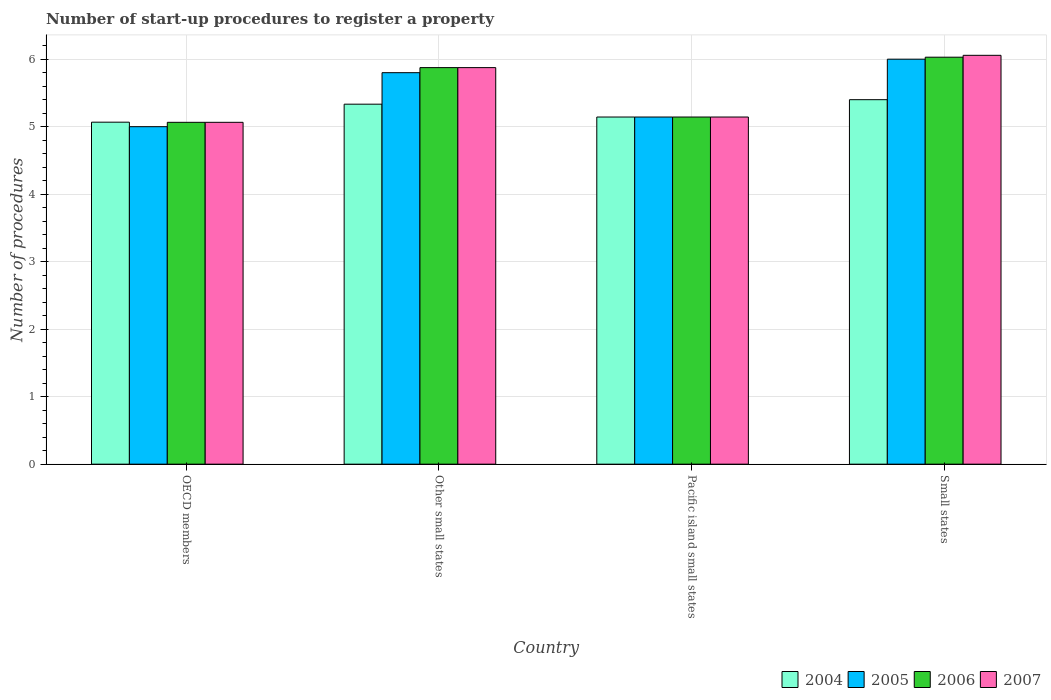How many groups of bars are there?
Make the answer very short. 4. Are the number of bars per tick equal to the number of legend labels?
Your response must be concise. Yes. How many bars are there on the 3rd tick from the left?
Provide a short and direct response. 4. What is the label of the 1st group of bars from the left?
Your response must be concise. OECD members. In how many cases, is the number of bars for a given country not equal to the number of legend labels?
Your answer should be very brief. 0. What is the number of procedures required to register a property in 2007 in Other small states?
Your answer should be compact. 5.88. Across all countries, what is the maximum number of procedures required to register a property in 2006?
Ensure brevity in your answer.  6.03. Across all countries, what is the minimum number of procedures required to register a property in 2005?
Make the answer very short. 5. In which country was the number of procedures required to register a property in 2006 maximum?
Give a very brief answer. Small states. In which country was the number of procedures required to register a property in 2005 minimum?
Offer a terse response. OECD members. What is the total number of procedures required to register a property in 2007 in the graph?
Offer a terse response. 22.14. What is the difference between the number of procedures required to register a property in 2004 in OECD members and that in Other small states?
Provide a succinct answer. -0.27. What is the difference between the number of procedures required to register a property in 2006 in Other small states and the number of procedures required to register a property in 2005 in Small states?
Your response must be concise. -0.12. What is the average number of procedures required to register a property in 2007 per country?
Give a very brief answer. 5.53. What is the difference between the number of procedures required to register a property of/in 2004 and number of procedures required to register a property of/in 2006 in Pacific island small states?
Offer a very short reply. 0. What is the ratio of the number of procedures required to register a property in 2005 in OECD members to that in Pacific island small states?
Provide a short and direct response. 0.97. Is the difference between the number of procedures required to register a property in 2004 in Pacific island small states and Small states greater than the difference between the number of procedures required to register a property in 2006 in Pacific island small states and Small states?
Your answer should be very brief. Yes. What is the difference between the highest and the second highest number of procedures required to register a property in 2007?
Your answer should be compact. -0.73. What is the difference between the highest and the lowest number of procedures required to register a property in 2005?
Your answer should be compact. 1. Is the sum of the number of procedures required to register a property in 2007 in Other small states and Pacific island small states greater than the maximum number of procedures required to register a property in 2006 across all countries?
Provide a succinct answer. Yes. What does the 1st bar from the right in OECD members represents?
Your answer should be compact. 2007. Is it the case that in every country, the sum of the number of procedures required to register a property in 2005 and number of procedures required to register a property in 2007 is greater than the number of procedures required to register a property in 2004?
Give a very brief answer. Yes. How many bars are there?
Your answer should be compact. 16. Are all the bars in the graph horizontal?
Give a very brief answer. No. How many countries are there in the graph?
Your response must be concise. 4. Are the values on the major ticks of Y-axis written in scientific E-notation?
Provide a succinct answer. No. Does the graph contain any zero values?
Offer a terse response. No. Where does the legend appear in the graph?
Keep it short and to the point. Bottom right. What is the title of the graph?
Keep it short and to the point. Number of start-up procedures to register a property. Does "2012" appear as one of the legend labels in the graph?
Offer a terse response. No. What is the label or title of the Y-axis?
Offer a very short reply. Number of procedures. What is the Number of procedures in 2004 in OECD members?
Offer a terse response. 5.07. What is the Number of procedures in 2006 in OECD members?
Provide a succinct answer. 5.06. What is the Number of procedures in 2007 in OECD members?
Your answer should be very brief. 5.06. What is the Number of procedures of 2004 in Other small states?
Offer a very short reply. 5.33. What is the Number of procedures in 2005 in Other small states?
Your answer should be compact. 5.8. What is the Number of procedures in 2006 in Other small states?
Your response must be concise. 5.88. What is the Number of procedures in 2007 in Other small states?
Keep it short and to the point. 5.88. What is the Number of procedures in 2004 in Pacific island small states?
Offer a terse response. 5.14. What is the Number of procedures of 2005 in Pacific island small states?
Provide a succinct answer. 5.14. What is the Number of procedures in 2006 in Pacific island small states?
Offer a very short reply. 5.14. What is the Number of procedures of 2007 in Pacific island small states?
Ensure brevity in your answer.  5.14. What is the Number of procedures in 2004 in Small states?
Provide a short and direct response. 5.4. What is the Number of procedures of 2006 in Small states?
Keep it short and to the point. 6.03. What is the Number of procedures of 2007 in Small states?
Give a very brief answer. 6.06. Across all countries, what is the maximum Number of procedures of 2005?
Keep it short and to the point. 6. Across all countries, what is the maximum Number of procedures of 2006?
Your answer should be very brief. 6.03. Across all countries, what is the maximum Number of procedures in 2007?
Keep it short and to the point. 6.06. Across all countries, what is the minimum Number of procedures of 2004?
Your answer should be compact. 5.07. Across all countries, what is the minimum Number of procedures in 2006?
Your answer should be very brief. 5.06. Across all countries, what is the minimum Number of procedures in 2007?
Give a very brief answer. 5.06. What is the total Number of procedures of 2004 in the graph?
Offer a very short reply. 20.94. What is the total Number of procedures of 2005 in the graph?
Make the answer very short. 21.94. What is the total Number of procedures in 2006 in the graph?
Ensure brevity in your answer.  22.11. What is the total Number of procedures in 2007 in the graph?
Ensure brevity in your answer.  22.14. What is the difference between the Number of procedures of 2004 in OECD members and that in Other small states?
Ensure brevity in your answer.  -0.27. What is the difference between the Number of procedures of 2006 in OECD members and that in Other small states?
Your answer should be compact. -0.81. What is the difference between the Number of procedures in 2007 in OECD members and that in Other small states?
Your answer should be compact. -0.81. What is the difference between the Number of procedures in 2004 in OECD members and that in Pacific island small states?
Offer a very short reply. -0.08. What is the difference between the Number of procedures in 2005 in OECD members and that in Pacific island small states?
Your response must be concise. -0.14. What is the difference between the Number of procedures of 2006 in OECD members and that in Pacific island small states?
Keep it short and to the point. -0.08. What is the difference between the Number of procedures of 2007 in OECD members and that in Pacific island small states?
Provide a short and direct response. -0.08. What is the difference between the Number of procedures in 2006 in OECD members and that in Small states?
Your answer should be very brief. -0.96. What is the difference between the Number of procedures in 2007 in OECD members and that in Small states?
Your response must be concise. -0.99. What is the difference between the Number of procedures of 2004 in Other small states and that in Pacific island small states?
Your answer should be compact. 0.19. What is the difference between the Number of procedures of 2005 in Other small states and that in Pacific island small states?
Offer a very short reply. 0.66. What is the difference between the Number of procedures in 2006 in Other small states and that in Pacific island small states?
Your answer should be very brief. 0.73. What is the difference between the Number of procedures of 2007 in Other small states and that in Pacific island small states?
Offer a very short reply. 0.73. What is the difference between the Number of procedures of 2004 in Other small states and that in Small states?
Ensure brevity in your answer.  -0.07. What is the difference between the Number of procedures in 2006 in Other small states and that in Small states?
Your answer should be compact. -0.15. What is the difference between the Number of procedures in 2007 in Other small states and that in Small states?
Your answer should be very brief. -0.18. What is the difference between the Number of procedures of 2004 in Pacific island small states and that in Small states?
Give a very brief answer. -0.26. What is the difference between the Number of procedures in 2005 in Pacific island small states and that in Small states?
Offer a very short reply. -0.86. What is the difference between the Number of procedures in 2006 in Pacific island small states and that in Small states?
Your answer should be very brief. -0.89. What is the difference between the Number of procedures in 2007 in Pacific island small states and that in Small states?
Make the answer very short. -0.91. What is the difference between the Number of procedures in 2004 in OECD members and the Number of procedures in 2005 in Other small states?
Give a very brief answer. -0.73. What is the difference between the Number of procedures of 2004 in OECD members and the Number of procedures of 2006 in Other small states?
Give a very brief answer. -0.81. What is the difference between the Number of procedures in 2004 in OECD members and the Number of procedures in 2007 in Other small states?
Offer a very short reply. -0.81. What is the difference between the Number of procedures of 2005 in OECD members and the Number of procedures of 2006 in Other small states?
Provide a succinct answer. -0.88. What is the difference between the Number of procedures of 2005 in OECD members and the Number of procedures of 2007 in Other small states?
Ensure brevity in your answer.  -0.88. What is the difference between the Number of procedures in 2006 in OECD members and the Number of procedures in 2007 in Other small states?
Provide a short and direct response. -0.81. What is the difference between the Number of procedures in 2004 in OECD members and the Number of procedures in 2005 in Pacific island small states?
Your answer should be compact. -0.08. What is the difference between the Number of procedures in 2004 in OECD members and the Number of procedures in 2006 in Pacific island small states?
Ensure brevity in your answer.  -0.08. What is the difference between the Number of procedures in 2004 in OECD members and the Number of procedures in 2007 in Pacific island small states?
Keep it short and to the point. -0.08. What is the difference between the Number of procedures in 2005 in OECD members and the Number of procedures in 2006 in Pacific island small states?
Make the answer very short. -0.14. What is the difference between the Number of procedures of 2005 in OECD members and the Number of procedures of 2007 in Pacific island small states?
Provide a short and direct response. -0.14. What is the difference between the Number of procedures in 2006 in OECD members and the Number of procedures in 2007 in Pacific island small states?
Ensure brevity in your answer.  -0.08. What is the difference between the Number of procedures in 2004 in OECD members and the Number of procedures in 2005 in Small states?
Your answer should be very brief. -0.93. What is the difference between the Number of procedures of 2004 in OECD members and the Number of procedures of 2006 in Small states?
Your response must be concise. -0.96. What is the difference between the Number of procedures in 2004 in OECD members and the Number of procedures in 2007 in Small states?
Provide a succinct answer. -0.99. What is the difference between the Number of procedures in 2005 in OECD members and the Number of procedures in 2006 in Small states?
Your response must be concise. -1.03. What is the difference between the Number of procedures of 2005 in OECD members and the Number of procedures of 2007 in Small states?
Make the answer very short. -1.06. What is the difference between the Number of procedures of 2006 in OECD members and the Number of procedures of 2007 in Small states?
Offer a very short reply. -0.99. What is the difference between the Number of procedures in 2004 in Other small states and the Number of procedures in 2005 in Pacific island small states?
Provide a short and direct response. 0.19. What is the difference between the Number of procedures of 2004 in Other small states and the Number of procedures of 2006 in Pacific island small states?
Your response must be concise. 0.19. What is the difference between the Number of procedures in 2004 in Other small states and the Number of procedures in 2007 in Pacific island small states?
Ensure brevity in your answer.  0.19. What is the difference between the Number of procedures of 2005 in Other small states and the Number of procedures of 2006 in Pacific island small states?
Provide a short and direct response. 0.66. What is the difference between the Number of procedures in 2005 in Other small states and the Number of procedures in 2007 in Pacific island small states?
Provide a short and direct response. 0.66. What is the difference between the Number of procedures of 2006 in Other small states and the Number of procedures of 2007 in Pacific island small states?
Keep it short and to the point. 0.73. What is the difference between the Number of procedures of 2004 in Other small states and the Number of procedures of 2005 in Small states?
Your response must be concise. -0.67. What is the difference between the Number of procedures in 2004 in Other small states and the Number of procedures in 2006 in Small states?
Provide a succinct answer. -0.7. What is the difference between the Number of procedures of 2004 in Other small states and the Number of procedures of 2007 in Small states?
Keep it short and to the point. -0.72. What is the difference between the Number of procedures in 2005 in Other small states and the Number of procedures in 2006 in Small states?
Offer a very short reply. -0.23. What is the difference between the Number of procedures in 2005 in Other small states and the Number of procedures in 2007 in Small states?
Give a very brief answer. -0.26. What is the difference between the Number of procedures of 2006 in Other small states and the Number of procedures of 2007 in Small states?
Give a very brief answer. -0.18. What is the difference between the Number of procedures of 2004 in Pacific island small states and the Number of procedures of 2005 in Small states?
Give a very brief answer. -0.86. What is the difference between the Number of procedures in 2004 in Pacific island small states and the Number of procedures in 2006 in Small states?
Offer a terse response. -0.89. What is the difference between the Number of procedures in 2004 in Pacific island small states and the Number of procedures in 2007 in Small states?
Provide a succinct answer. -0.91. What is the difference between the Number of procedures in 2005 in Pacific island small states and the Number of procedures in 2006 in Small states?
Offer a terse response. -0.89. What is the difference between the Number of procedures in 2005 in Pacific island small states and the Number of procedures in 2007 in Small states?
Your answer should be compact. -0.91. What is the difference between the Number of procedures in 2006 in Pacific island small states and the Number of procedures in 2007 in Small states?
Ensure brevity in your answer.  -0.91. What is the average Number of procedures of 2004 per country?
Offer a terse response. 5.24. What is the average Number of procedures of 2005 per country?
Your response must be concise. 5.49. What is the average Number of procedures in 2006 per country?
Provide a succinct answer. 5.53. What is the average Number of procedures of 2007 per country?
Your answer should be compact. 5.53. What is the difference between the Number of procedures in 2004 and Number of procedures in 2005 in OECD members?
Your response must be concise. 0.07. What is the difference between the Number of procedures in 2004 and Number of procedures in 2006 in OECD members?
Provide a short and direct response. 0. What is the difference between the Number of procedures in 2004 and Number of procedures in 2007 in OECD members?
Keep it short and to the point. 0. What is the difference between the Number of procedures of 2005 and Number of procedures of 2006 in OECD members?
Provide a succinct answer. -0.06. What is the difference between the Number of procedures in 2005 and Number of procedures in 2007 in OECD members?
Offer a terse response. -0.06. What is the difference between the Number of procedures of 2004 and Number of procedures of 2005 in Other small states?
Your answer should be very brief. -0.47. What is the difference between the Number of procedures in 2004 and Number of procedures in 2006 in Other small states?
Keep it short and to the point. -0.54. What is the difference between the Number of procedures in 2004 and Number of procedures in 2007 in Other small states?
Ensure brevity in your answer.  -0.54. What is the difference between the Number of procedures in 2005 and Number of procedures in 2006 in Other small states?
Keep it short and to the point. -0.07. What is the difference between the Number of procedures in 2005 and Number of procedures in 2007 in Other small states?
Provide a succinct answer. -0.07. What is the difference between the Number of procedures in 2006 and Number of procedures in 2007 in Other small states?
Offer a terse response. 0. What is the difference between the Number of procedures in 2004 and Number of procedures in 2006 in Pacific island small states?
Offer a terse response. 0. What is the difference between the Number of procedures in 2005 and Number of procedures in 2006 in Pacific island small states?
Make the answer very short. 0. What is the difference between the Number of procedures in 2004 and Number of procedures in 2006 in Small states?
Keep it short and to the point. -0.63. What is the difference between the Number of procedures in 2004 and Number of procedures in 2007 in Small states?
Ensure brevity in your answer.  -0.66. What is the difference between the Number of procedures of 2005 and Number of procedures of 2006 in Small states?
Provide a short and direct response. -0.03. What is the difference between the Number of procedures of 2005 and Number of procedures of 2007 in Small states?
Provide a succinct answer. -0.06. What is the difference between the Number of procedures of 2006 and Number of procedures of 2007 in Small states?
Your answer should be compact. -0.03. What is the ratio of the Number of procedures in 2004 in OECD members to that in Other small states?
Your answer should be compact. 0.95. What is the ratio of the Number of procedures in 2005 in OECD members to that in Other small states?
Provide a succinct answer. 0.86. What is the ratio of the Number of procedures in 2006 in OECD members to that in Other small states?
Provide a short and direct response. 0.86. What is the ratio of the Number of procedures of 2007 in OECD members to that in Other small states?
Keep it short and to the point. 0.86. What is the ratio of the Number of procedures in 2004 in OECD members to that in Pacific island small states?
Give a very brief answer. 0.99. What is the ratio of the Number of procedures in 2005 in OECD members to that in Pacific island small states?
Provide a short and direct response. 0.97. What is the ratio of the Number of procedures in 2006 in OECD members to that in Pacific island small states?
Ensure brevity in your answer.  0.98. What is the ratio of the Number of procedures in 2004 in OECD members to that in Small states?
Ensure brevity in your answer.  0.94. What is the ratio of the Number of procedures of 2005 in OECD members to that in Small states?
Keep it short and to the point. 0.83. What is the ratio of the Number of procedures in 2006 in OECD members to that in Small states?
Offer a terse response. 0.84. What is the ratio of the Number of procedures in 2007 in OECD members to that in Small states?
Your response must be concise. 0.84. What is the ratio of the Number of procedures of 2004 in Other small states to that in Pacific island small states?
Ensure brevity in your answer.  1.04. What is the ratio of the Number of procedures in 2005 in Other small states to that in Pacific island small states?
Your answer should be very brief. 1.13. What is the ratio of the Number of procedures of 2006 in Other small states to that in Pacific island small states?
Ensure brevity in your answer.  1.14. What is the ratio of the Number of procedures in 2007 in Other small states to that in Pacific island small states?
Your answer should be very brief. 1.14. What is the ratio of the Number of procedures in 2004 in Other small states to that in Small states?
Give a very brief answer. 0.99. What is the ratio of the Number of procedures in 2005 in Other small states to that in Small states?
Your response must be concise. 0.97. What is the ratio of the Number of procedures of 2006 in Other small states to that in Small states?
Ensure brevity in your answer.  0.97. What is the ratio of the Number of procedures in 2007 in Other small states to that in Small states?
Your answer should be compact. 0.97. What is the ratio of the Number of procedures of 2004 in Pacific island small states to that in Small states?
Offer a terse response. 0.95. What is the ratio of the Number of procedures of 2005 in Pacific island small states to that in Small states?
Offer a very short reply. 0.86. What is the ratio of the Number of procedures in 2006 in Pacific island small states to that in Small states?
Provide a succinct answer. 0.85. What is the ratio of the Number of procedures of 2007 in Pacific island small states to that in Small states?
Your response must be concise. 0.85. What is the difference between the highest and the second highest Number of procedures in 2004?
Your answer should be compact. 0.07. What is the difference between the highest and the second highest Number of procedures in 2005?
Offer a terse response. 0.2. What is the difference between the highest and the second highest Number of procedures of 2006?
Ensure brevity in your answer.  0.15. What is the difference between the highest and the second highest Number of procedures of 2007?
Your response must be concise. 0.18. What is the difference between the highest and the lowest Number of procedures in 2006?
Ensure brevity in your answer.  0.96. What is the difference between the highest and the lowest Number of procedures in 2007?
Your response must be concise. 0.99. 